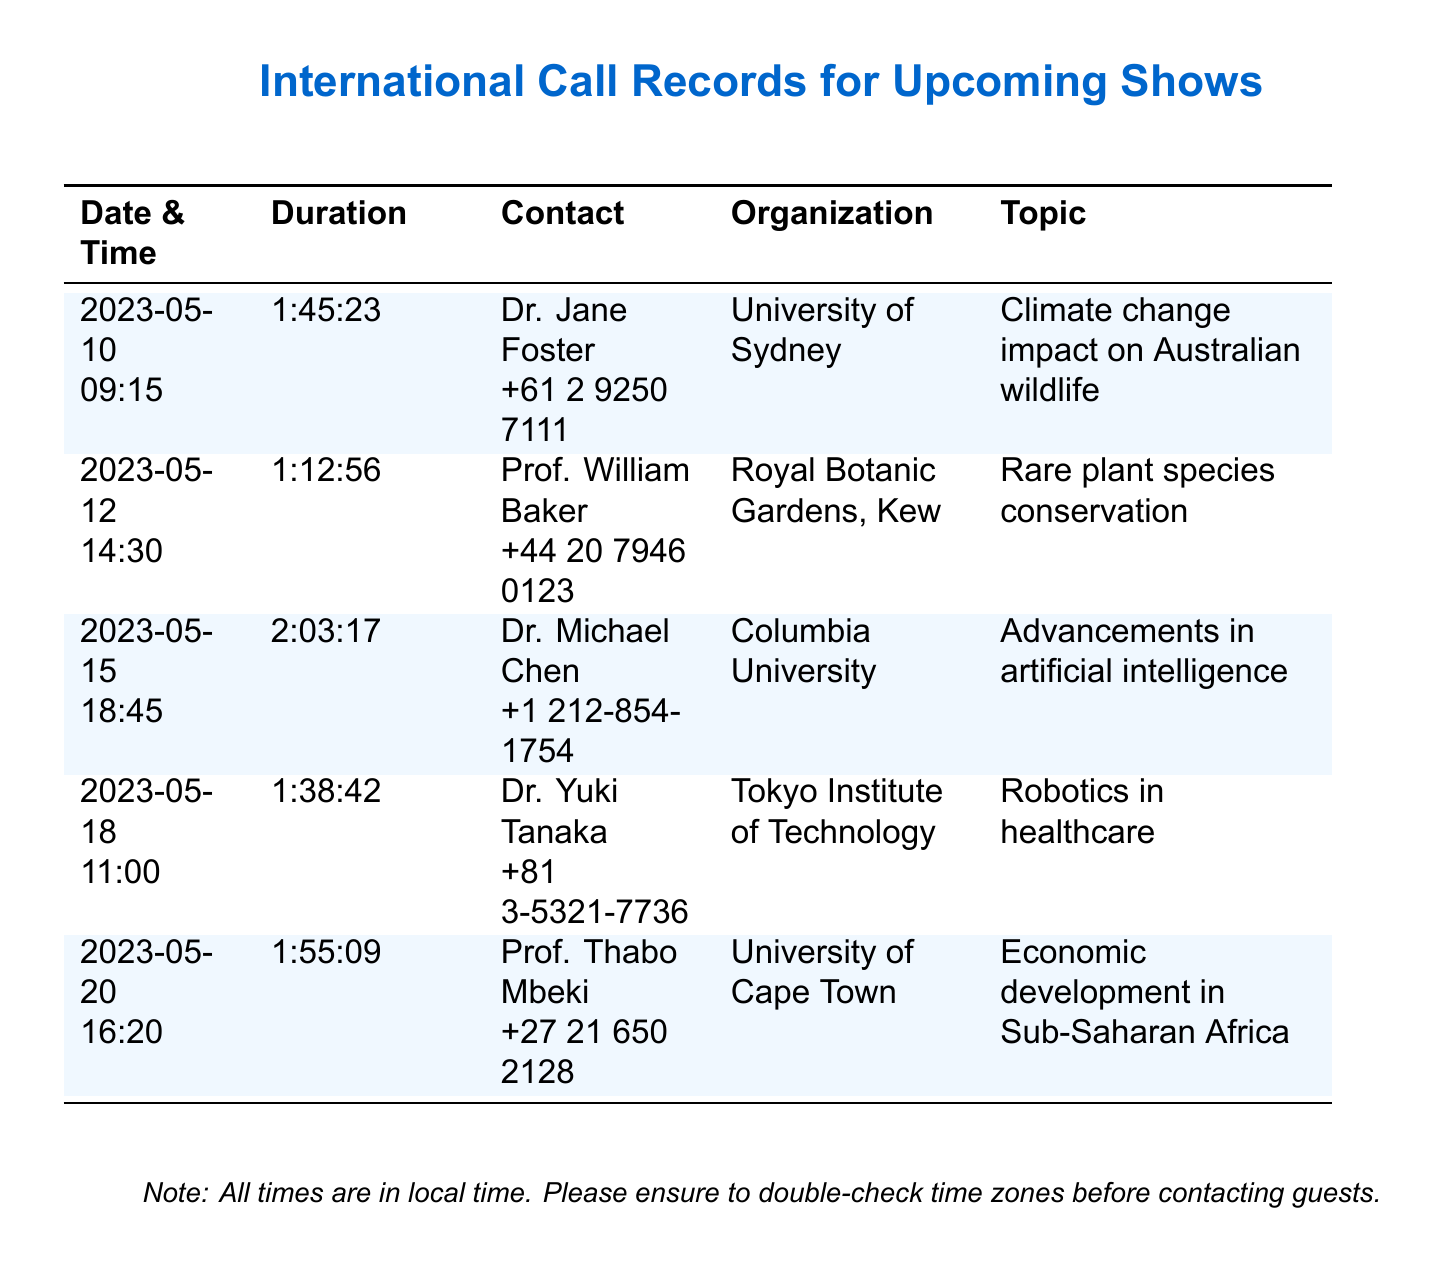What is the date of the longest call? The longest call is with Dr. Michael Chen on May 15, 2023, lasting 2 hours and 3 minutes.
Answer: 2023-05-15 Who is associated with the topic of robotics in healthcare? The document lists Dr. Yuki Tanaka as the contact for the topic of robotics in healthcare.
Answer: Dr. Yuki Tanaka What is the duration of the call with Prof. William Baker? The document states that the call with Prof. William Baker lasted 1 hour and 12 minutes.
Answer: 1:12:56 Which organization is Dr. Jane Foster affiliated with? Dr. Jane Foster is affiliated with the University of Sydney as per the document.
Answer: University of Sydney How many calls are listed in the document? The document includes five calls listed in the table.
Answer: 5 What are the main topics discussed in the calls? The topics discussed include climate change, rare plant species, artificial intelligence, robotics, and economic development.
Answer: Climate change, rare plant species, artificial intelligence, robotics, economic development What is the contact number for Prof. Thabo Mbeki? The document provides Prof. Thabo Mbeki's contact number as +27 21 650 2128.
Answer: +27 21 650 2128 Which call took place on May 20, 2023? The call on May 20, 2023, was with Prof. Thabo Mbeki to discuss economic development in Sub-Saharan Africa.
Answer: Prof. Thabo Mbeki What is the local time for the call with Dr. Yuki Tanaka? The document states that Dr. Yuki Tanaka's call was at 11:00 local time.
Answer: 11:00 